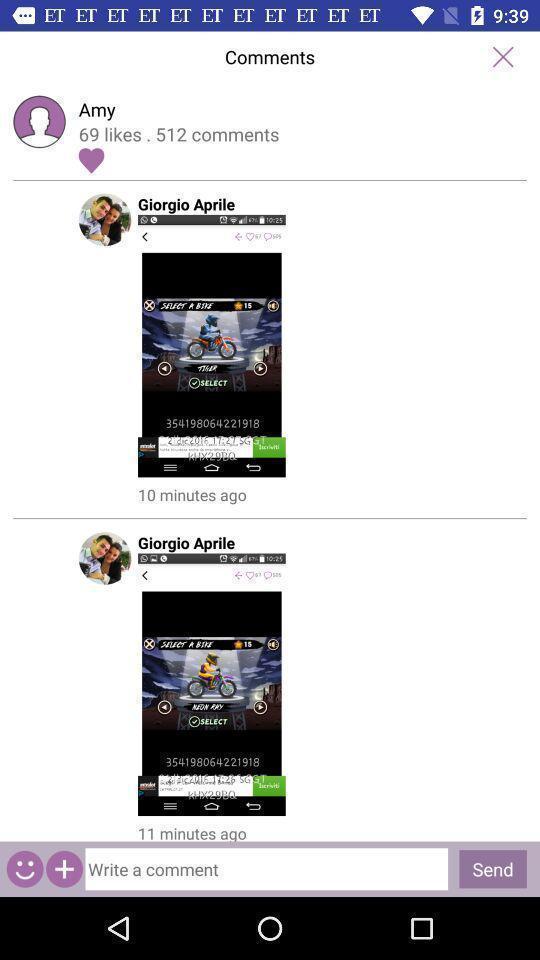Give me a summary of this screen capture. Page showing information from a social media app. 